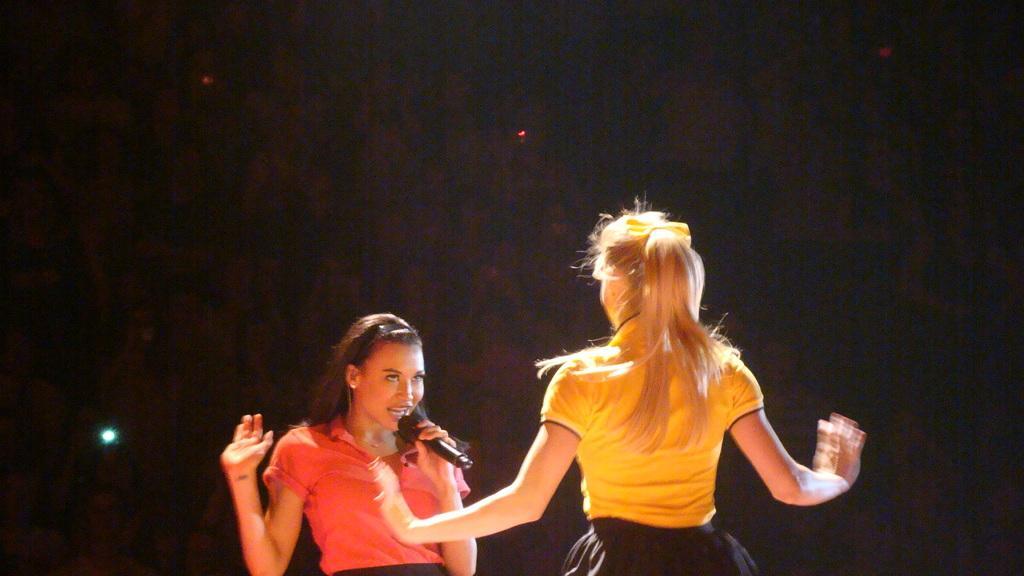Could you give a brief overview of what you see in this image? In this image we can see two ladies, one of them is holding a mic and singing, there are lights, and the background is dark. 